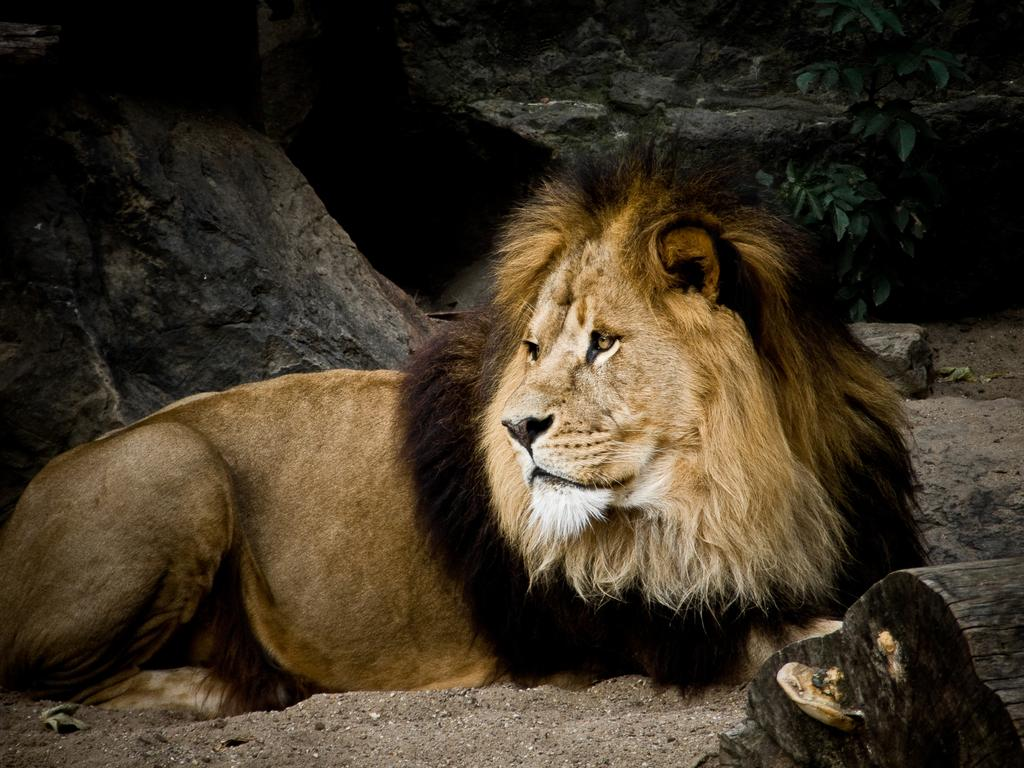What type of animal is in the image? There is a lion in the image. What type of natural formations can be seen in the image? There are rocks in the image. What type of plant material is present in the image? There are leaves in the image. What other unspecified objects can be seen in the image? There are unspecified objects in the image. What type of bit is the lion using to communicate with the other animals in the image? There is no indication in the image that the lion is using any type of bit to communicate with other animals. 